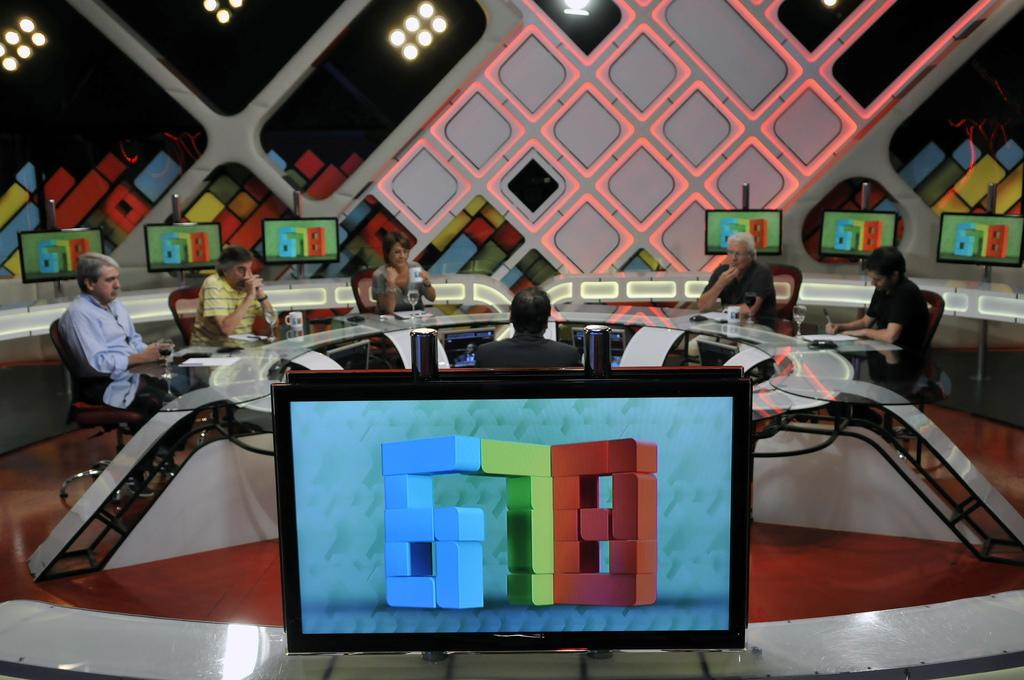Provide a one-sentence caption for the provided image. People are gathered around a table while several televisions display the numbers 6 7 8. 